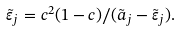Convert formula to latex. <formula><loc_0><loc_0><loc_500><loc_500>\tilde { \varepsilon } _ { j } = { c ^ { 2 } ( 1 - c ) } / ( { \tilde { a } _ { j } - \tilde { \varepsilon } _ { j } } ) .</formula> 